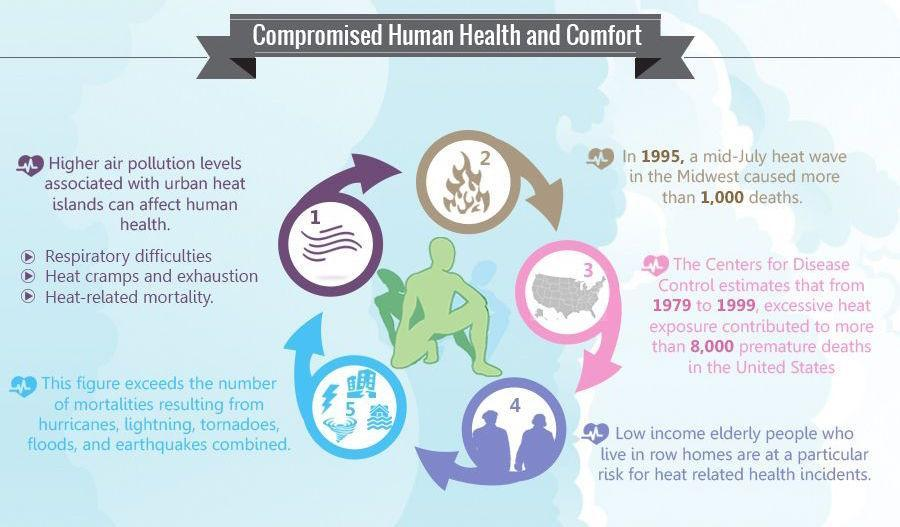What caused premature deaths in the US?
Answer the question with a short phrase. Excessive heat exposure Apart from heat-mortalities, what are some of the other causes of mortality in the US? Hurricanes, lightning, tornadoes, floods, and earthquakes How many points are mentioned here? 5 In which region in US, did mid-July heat waves take away a thousand lives? Midwest Who are at highest risk of health issues caused due to heat? Low income elderly people who live in row homes What are the health problems associated with high air pollution levels in urban heat Islands? Respiratory difficulties, heat cramps and exhaustion, heat-related mortality 